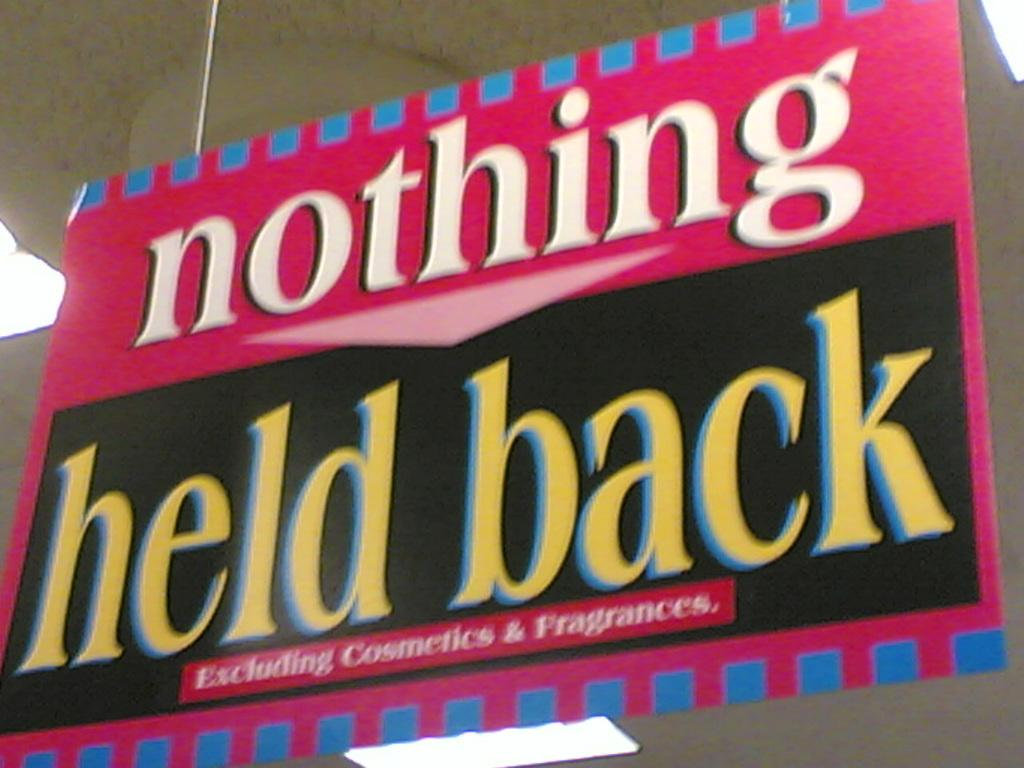<image>
Give a short and clear explanation of the subsequent image. the word nothing is on the red sign 